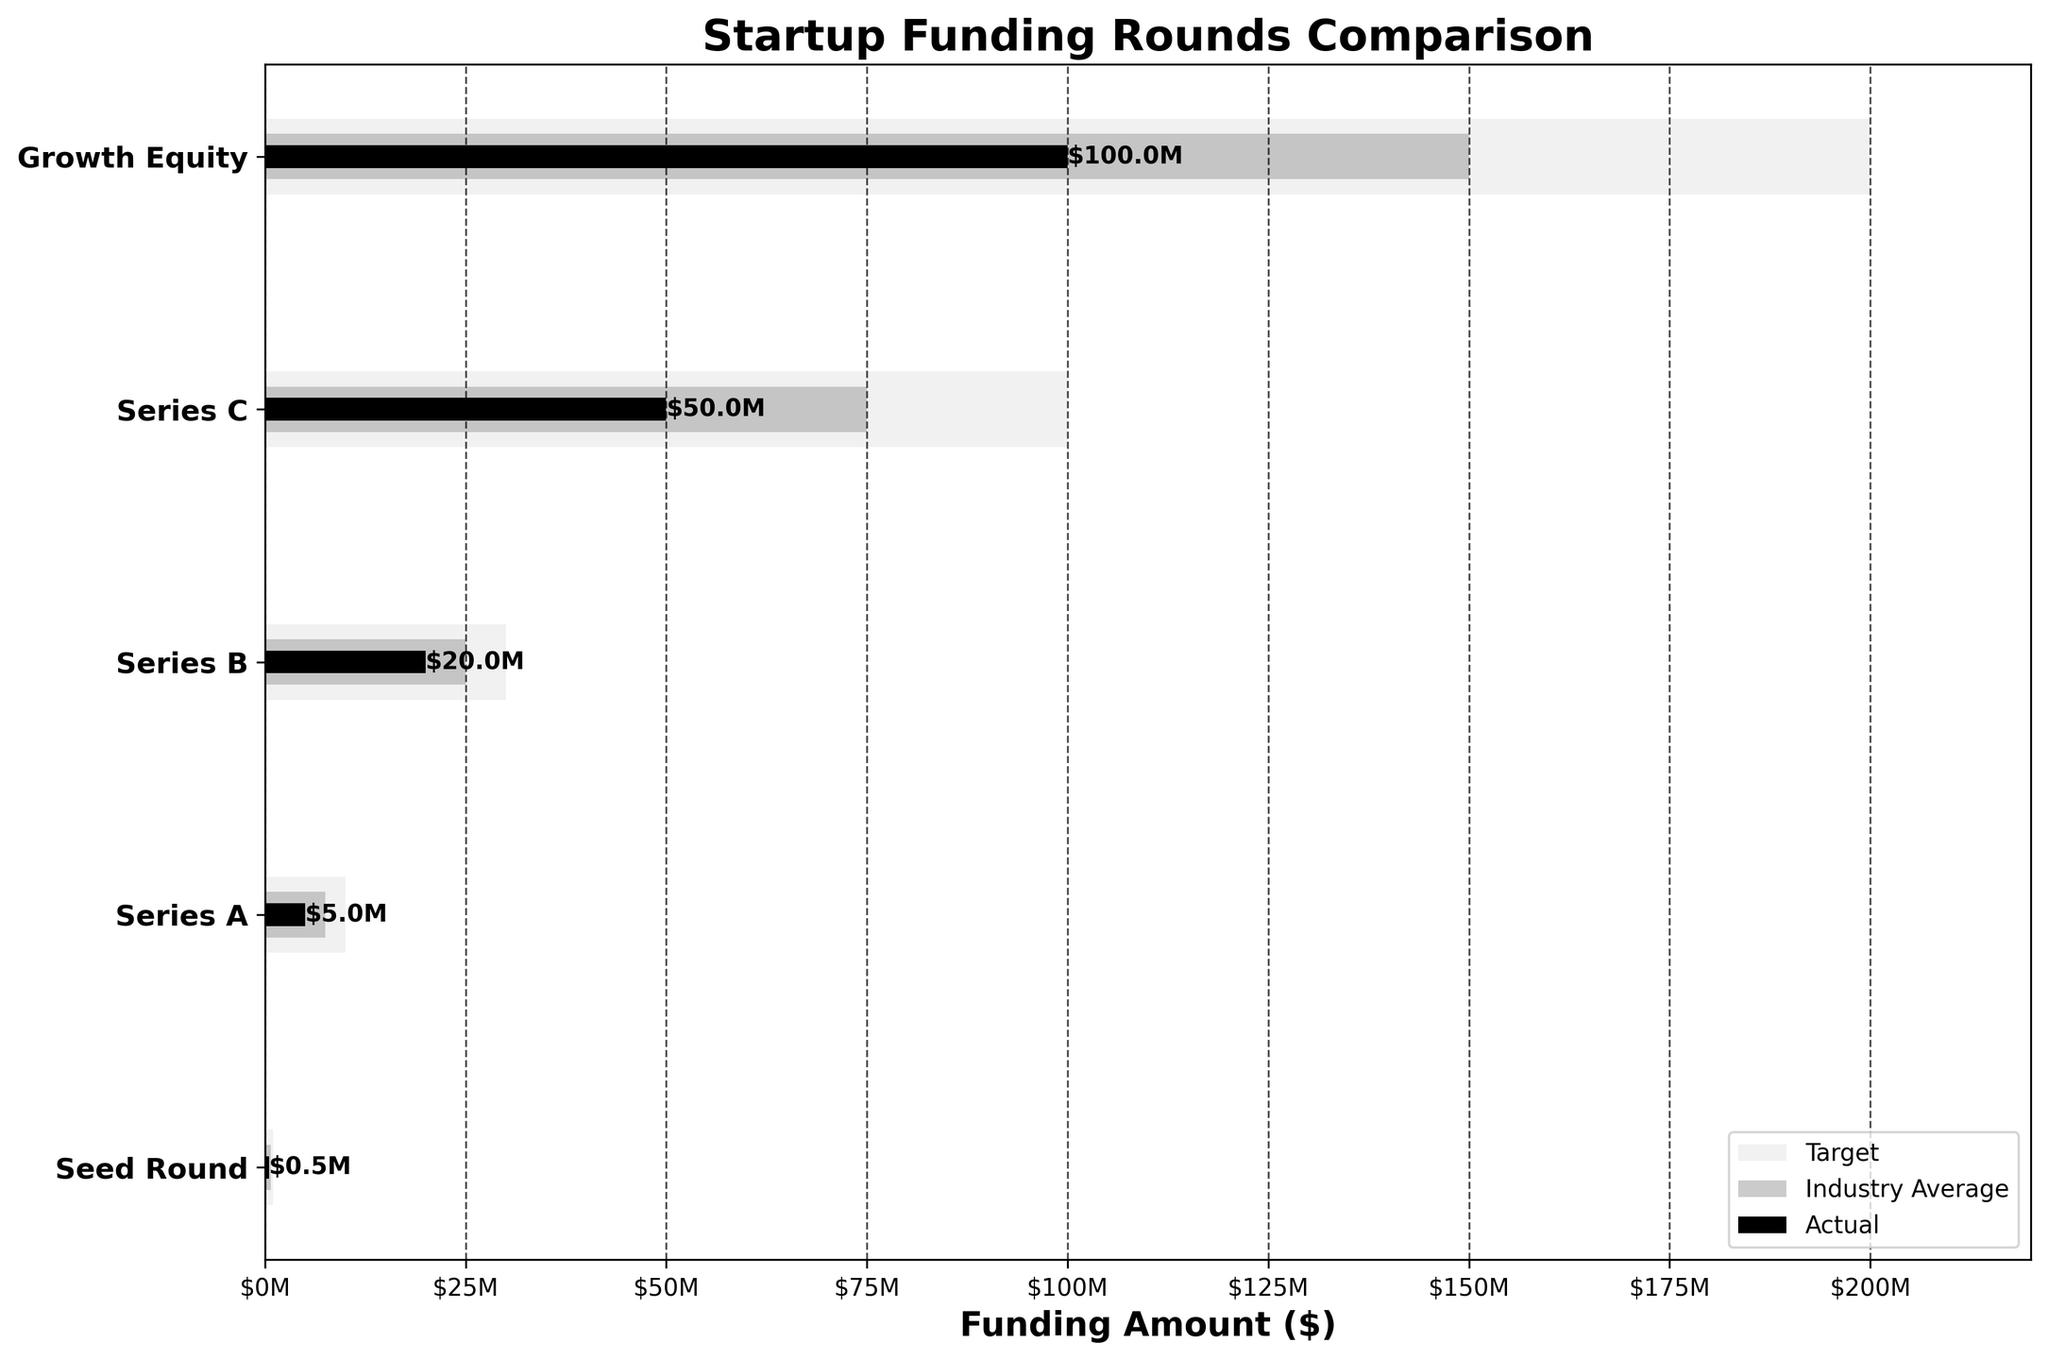What's the title of the figure? The title of the figure is usually prominently displayed at the top. In this case, it reads "Startup Funding Rounds Comparison".
Answer: Startup Funding Rounds Comparison What does the x-axis represent? The x-axis label provides information about the variable being measured along the horizontal axis. Here, it is labeled as 'Funding Amount ($)', indicating the amount of funding in dollars.
Answer: Funding Amount ($) Which funding round has the highest target amount? To identify the highest target amount, look at the target bars (light grey) and determine which is the longest. The Growth Equity round clearly has the highest target of $200 million.
Answer: Growth Equity How much actual funding was received in the Series B round? Refer to the black bar for the Series B round to find the funding amount. It ends at the $20M mark.
Answer: $20 million In which round is the actual funding furthest below its target? Compare the difference between the black bar (actual) and the light grey bar (target) for each round. The Seed Round has the greatest difference since its actual funding ($0.5M) is much lower than its target of $1M.
Answer: Seed Round Is there any round where the actual funding matches the industry average? Compare the black bars (actual) with the dark grey bars (industry average). There is no instance where the actual funding exactly matches the industry average in any round.
Answer: No What is the combined target amount for Series A and Series B rounds? Add the target amounts for both Series A ($10M) and Series B ($30M). The total combined target amount is $10M + $30M = $40M.
Answer: $40 million Which funding round shows the best performance relative to the industry average? To determine the best performance, calculate the ratio of actual funding to industry average for each round. Growth Equity has the highest actual funding of $100M compared to an industry average of $150M, which is the best relative performance.
Answer: Growth Equity How does the actual funding of Series C compare to Series A? Compare the lengths of the black bars for Series C and Series A. The actual funding for Series C ($50M) is significantly higher than for Series A ($5M).
Answer: Series C is higher What percentage of the target funding was achieved by the Series B round? To calculate the percentage, divide the actual funding ($20M) by the target funding ($30M) and multiply by 100. The resulting percentage is (20M / 30M) * 100 = approximately 66.67%.
Answer: Approximately 66.67% 